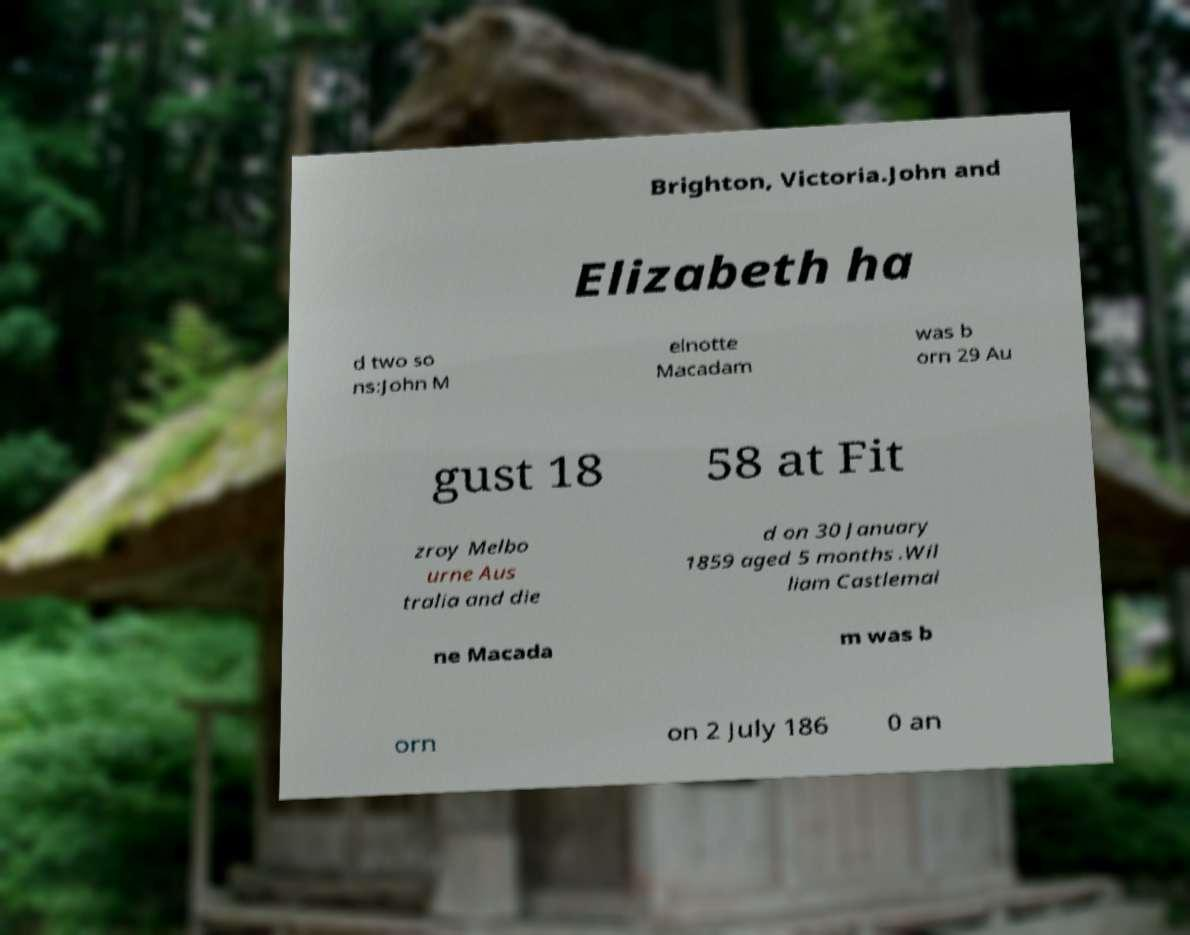Can you accurately transcribe the text from the provided image for me? Brighton, Victoria.John and Elizabeth ha d two so ns:John M elnotte Macadam was b orn 29 Au gust 18 58 at Fit zroy Melbo urne Aus tralia and die d on 30 January 1859 aged 5 months .Wil liam Castlemai ne Macada m was b orn on 2 July 186 0 an 